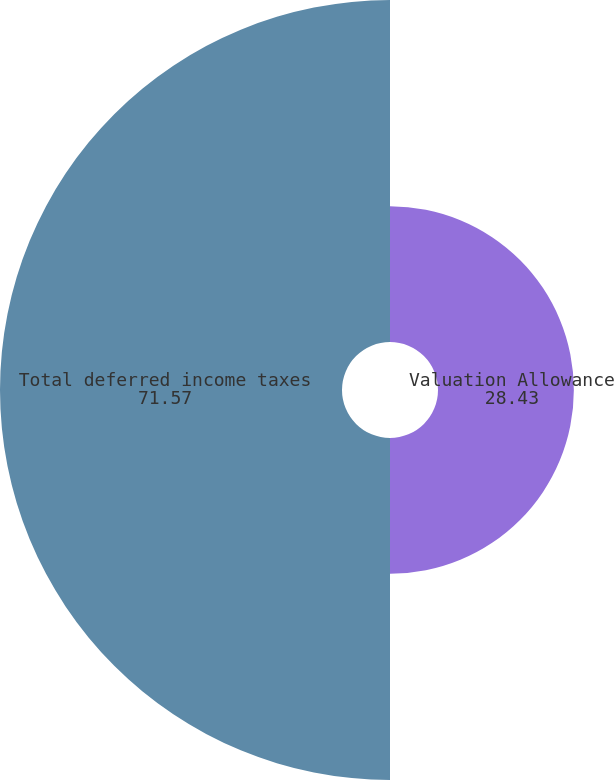<chart> <loc_0><loc_0><loc_500><loc_500><pie_chart><fcel>Valuation Allowance<fcel>Total deferred income taxes<nl><fcel>28.43%<fcel>71.57%<nl></chart> 